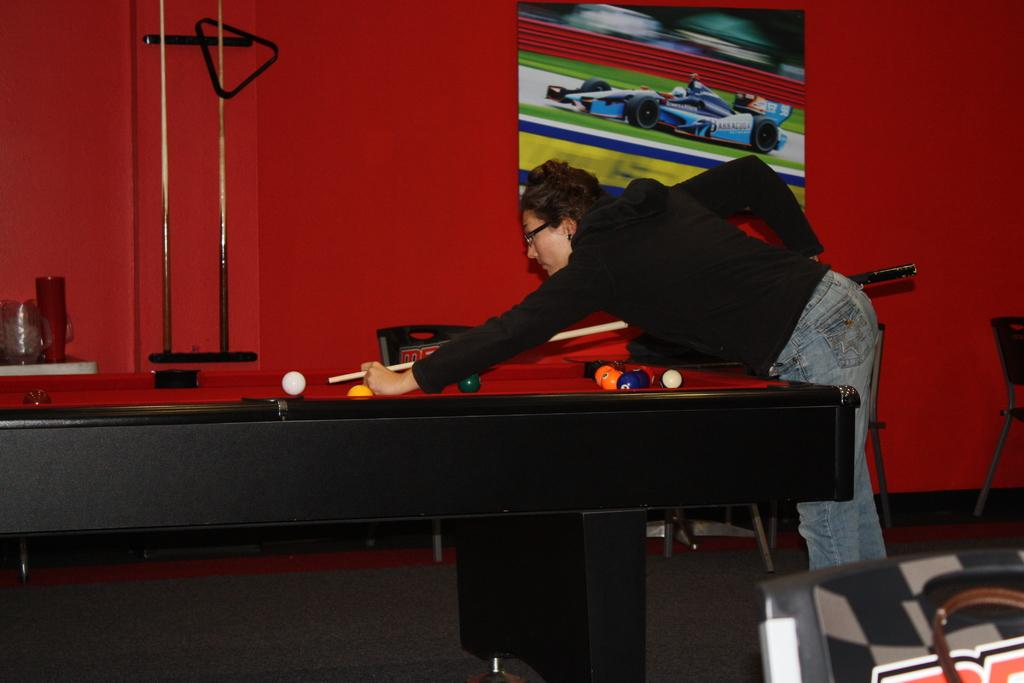Who is the main subject in the image? There is a person in the image. What is the person holding in the image? The person is holding a billiard stick. What activity is the person engaged in? The person is playing billiards on a billiards board. What color is the wall in the background? The wall in the background is red. What type of plant can be seen growing in the wilderness in the image? There is no plant or wilderness present in the image; it features a person playing billiards on a billiards board with a red wall in the background. 